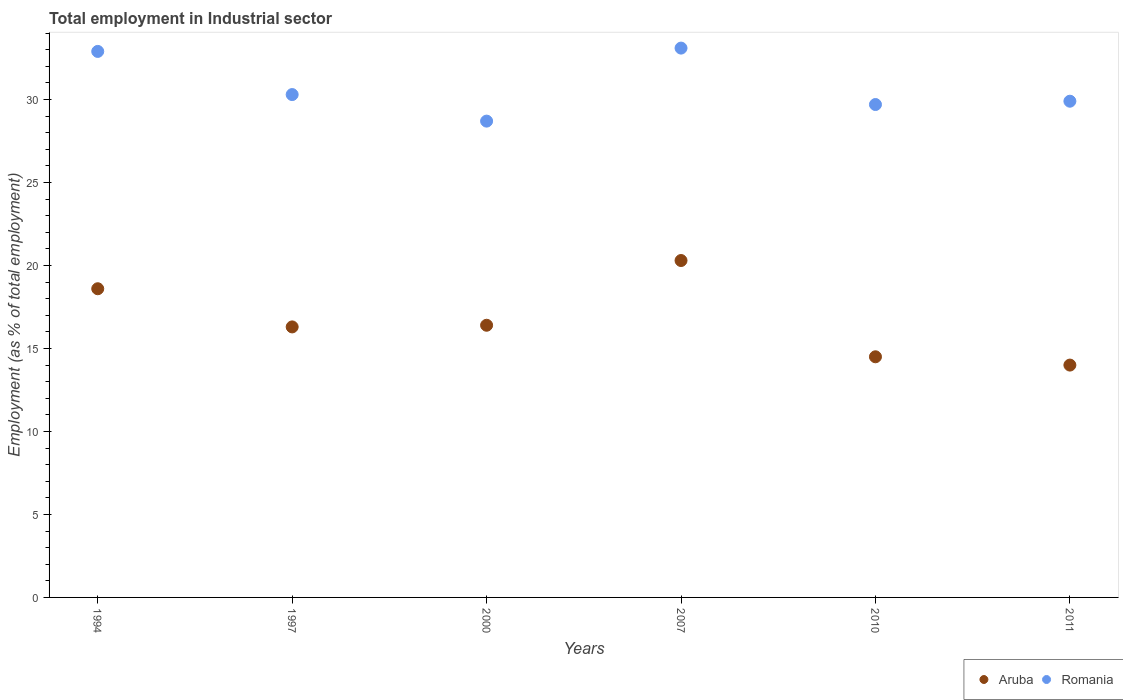How many different coloured dotlines are there?
Offer a terse response. 2. Is the number of dotlines equal to the number of legend labels?
Your answer should be compact. Yes. What is the employment in industrial sector in Romania in 2007?
Provide a short and direct response. 33.1. Across all years, what is the maximum employment in industrial sector in Aruba?
Make the answer very short. 20.3. Across all years, what is the minimum employment in industrial sector in Romania?
Give a very brief answer. 28.7. In which year was the employment in industrial sector in Romania maximum?
Provide a short and direct response. 2007. What is the total employment in industrial sector in Aruba in the graph?
Your answer should be very brief. 100.1. What is the difference between the employment in industrial sector in Romania in 1994 and that in 2011?
Your answer should be compact. 3. What is the difference between the employment in industrial sector in Romania in 1994 and the employment in industrial sector in Aruba in 1997?
Keep it short and to the point. 16.6. What is the average employment in industrial sector in Aruba per year?
Your response must be concise. 16.68. In the year 2007, what is the difference between the employment in industrial sector in Aruba and employment in industrial sector in Romania?
Offer a very short reply. -12.8. What is the ratio of the employment in industrial sector in Aruba in 1997 to that in 2011?
Your response must be concise. 1.16. Is the difference between the employment in industrial sector in Aruba in 1994 and 2000 greater than the difference between the employment in industrial sector in Romania in 1994 and 2000?
Offer a very short reply. No. What is the difference between the highest and the second highest employment in industrial sector in Aruba?
Provide a succinct answer. 1.7. What is the difference between the highest and the lowest employment in industrial sector in Romania?
Provide a succinct answer. 4.4. In how many years, is the employment in industrial sector in Romania greater than the average employment in industrial sector in Romania taken over all years?
Your response must be concise. 2. Is the sum of the employment in industrial sector in Aruba in 1994 and 1997 greater than the maximum employment in industrial sector in Romania across all years?
Provide a succinct answer. Yes. Does the employment in industrial sector in Aruba monotonically increase over the years?
Provide a short and direct response. No. Is the employment in industrial sector in Aruba strictly greater than the employment in industrial sector in Romania over the years?
Your answer should be very brief. No. Is the employment in industrial sector in Aruba strictly less than the employment in industrial sector in Romania over the years?
Make the answer very short. Yes. How many years are there in the graph?
Make the answer very short. 6. Does the graph contain grids?
Your answer should be compact. No. What is the title of the graph?
Ensure brevity in your answer.  Total employment in Industrial sector. Does "Puerto Rico" appear as one of the legend labels in the graph?
Give a very brief answer. No. What is the label or title of the Y-axis?
Offer a very short reply. Employment (as % of total employment). What is the Employment (as % of total employment) of Aruba in 1994?
Give a very brief answer. 18.6. What is the Employment (as % of total employment) of Romania in 1994?
Offer a terse response. 32.9. What is the Employment (as % of total employment) of Aruba in 1997?
Ensure brevity in your answer.  16.3. What is the Employment (as % of total employment) of Romania in 1997?
Give a very brief answer. 30.3. What is the Employment (as % of total employment) of Aruba in 2000?
Your answer should be very brief. 16.4. What is the Employment (as % of total employment) in Romania in 2000?
Give a very brief answer. 28.7. What is the Employment (as % of total employment) of Aruba in 2007?
Provide a succinct answer. 20.3. What is the Employment (as % of total employment) of Romania in 2007?
Give a very brief answer. 33.1. What is the Employment (as % of total employment) in Romania in 2010?
Your response must be concise. 29.7. What is the Employment (as % of total employment) of Romania in 2011?
Your response must be concise. 29.9. Across all years, what is the maximum Employment (as % of total employment) of Aruba?
Your response must be concise. 20.3. Across all years, what is the maximum Employment (as % of total employment) of Romania?
Give a very brief answer. 33.1. Across all years, what is the minimum Employment (as % of total employment) in Romania?
Provide a short and direct response. 28.7. What is the total Employment (as % of total employment) of Aruba in the graph?
Provide a short and direct response. 100.1. What is the total Employment (as % of total employment) of Romania in the graph?
Your answer should be very brief. 184.6. What is the difference between the Employment (as % of total employment) of Aruba in 1994 and that in 1997?
Your answer should be compact. 2.3. What is the difference between the Employment (as % of total employment) of Aruba in 1994 and that in 2000?
Your answer should be compact. 2.2. What is the difference between the Employment (as % of total employment) in Romania in 1994 and that in 2000?
Provide a succinct answer. 4.2. What is the difference between the Employment (as % of total employment) of Romania in 1994 and that in 2007?
Make the answer very short. -0.2. What is the difference between the Employment (as % of total employment) of Aruba in 1994 and that in 2010?
Provide a short and direct response. 4.1. What is the difference between the Employment (as % of total employment) of Romania in 1994 and that in 2010?
Offer a terse response. 3.2. What is the difference between the Employment (as % of total employment) in Aruba in 1994 and that in 2011?
Give a very brief answer. 4.6. What is the difference between the Employment (as % of total employment) of Romania in 1994 and that in 2011?
Offer a very short reply. 3. What is the difference between the Employment (as % of total employment) in Aruba in 1997 and that in 2000?
Provide a short and direct response. -0.1. What is the difference between the Employment (as % of total employment) in Romania in 1997 and that in 2000?
Your answer should be compact. 1.6. What is the difference between the Employment (as % of total employment) in Aruba in 1997 and that in 2010?
Give a very brief answer. 1.8. What is the difference between the Employment (as % of total employment) of Aruba in 1997 and that in 2011?
Your answer should be very brief. 2.3. What is the difference between the Employment (as % of total employment) of Romania in 1997 and that in 2011?
Your response must be concise. 0.4. What is the difference between the Employment (as % of total employment) of Romania in 2000 and that in 2007?
Offer a very short reply. -4.4. What is the difference between the Employment (as % of total employment) in Aruba in 2000 and that in 2010?
Offer a very short reply. 1.9. What is the difference between the Employment (as % of total employment) of Romania in 2000 and that in 2010?
Provide a short and direct response. -1. What is the difference between the Employment (as % of total employment) of Romania in 2000 and that in 2011?
Make the answer very short. -1.2. What is the difference between the Employment (as % of total employment) of Aruba in 2010 and that in 2011?
Provide a short and direct response. 0.5. What is the difference between the Employment (as % of total employment) of Aruba in 1994 and the Employment (as % of total employment) of Romania in 1997?
Your answer should be compact. -11.7. What is the difference between the Employment (as % of total employment) of Aruba in 1994 and the Employment (as % of total employment) of Romania in 2007?
Keep it short and to the point. -14.5. What is the difference between the Employment (as % of total employment) of Aruba in 1994 and the Employment (as % of total employment) of Romania in 2010?
Your answer should be very brief. -11.1. What is the difference between the Employment (as % of total employment) in Aruba in 1994 and the Employment (as % of total employment) in Romania in 2011?
Provide a succinct answer. -11.3. What is the difference between the Employment (as % of total employment) in Aruba in 1997 and the Employment (as % of total employment) in Romania in 2007?
Give a very brief answer. -16.8. What is the difference between the Employment (as % of total employment) of Aruba in 1997 and the Employment (as % of total employment) of Romania in 2010?
Ensure brevity in your answer.  -13.4. What is the difference between the Employment (as % of total employment) of Aruba in 2000 and the Employment (as % of total employment) of Romania in 2007?
Keep it short and to the point. -16.7. What is the difference between the Employment (as % of total employment) in Aruba in 2000 and the Employment (as % of total employment) in Romania in 2010?
Give a very brief answer. -13.3. What is the difference between the Employment (as % of total employment) in Aruba in 2000 and the Employment (as % of total employment) in Romania in 2011?
Provide a succinct answer. -13.5. What is the difference between the Employment (as % of total employment) of Aruba in 2007 and the Employment (as % of total employment) of Romania in 2010?
Offer a terse response. -9.4. What is the difference between the Employment (as % of total employment) in Aruba in 2007 and the Employment (as % of total employment) in Romania in 2011?
Your answer should be compact. -9.6. What is the difference between the Employment (as % of total employment) of Aruba in 2010 and the Employment (as % of total employment) of Romania in 2011?
Ensure brevity in your answer.  -15.4. What is the average Employment (as % of total employment) of Aruba per year?
Make the answer very short. 16.68. What is the average Employment (as % of total employment) of Romania per year?
Your answer should be very brief. 30.77. In the year 1994, what is the difference between the Employment (as % of total employment) in Aruba and Employment (as % of total employment) in Romania?
Ensure brevity in your answer.  -14.3. In the year 2000, what is the difference between the Employment (as % of total employment) of Aruba and Employment (as % of total employment) of Romania?
Offer a very short reply. -12.3. In the year 2007, what is the difference between the Employment (as % of total employment) in Aruba and Employment (as % of total employment) in Romania?
Offer a terse response. -12.8. In the year 2010, what is the difference between the Employment (as % of total employment) in Aruba and Employment (as % of total employment) in Romania?
Make the answer very short. -15.2. In the year 2011, what is the difference between the Employment (as % of total employment) in Aruba and Employment (as % of total employment) in Romania?
Offer a very short reply. -15.9. What is the ratio of the Employment (as % of total employment) of Aruba in 1994 to that in 1997?
Provide a succinct answer. 1.14. What is the ratio of the Employment (as % of total employment) in Romania in 1994 to that in 1997?
Provide a succinct answer. 1.09. What is the ratio of the Employment (as % of total employment) in Aruba in 1994 to that in 2000?
Keep it short and to the point. 1.13. What is the ratio of the Employment (as % of total employment) in Romania in 1994 to that in 2000?
Provide a succinct answer. 1.15. What is the ratio of the Employment (as % of total employment) in Aruba in 1994 to that in 2007?
Offer a very short reply. 0.92. What is the ratio of the Employment (as % of total employment) of Romania in 1994 to that in 2007?
Make the answer very short. 0.99. What is the ratio of the Employment (as % of total employment) in Aruba in 1994 to that in 2010?
Make the answer very short. 1.28. What is the ratio of the Employment (as % of total employment) in Romania in 1994 to that in 2010?
Make the answer very short. 1.11. What is the ratio of the Employment (as % of total employment) in Aruba in 1994 to that in 2011?
Provide a succinct answer. 1.33. What is the ratio of the Employment (as % of total employment) in Romania in 1994 to that in 2011?
Your answer should be very brief. 1.1. What is the ratio of the Employment (as % of total employment) in Romania in 1997 to that in 2000?
Your answer should be compact. 1.06. What is the ratio of the Employment (as % of total employment) in Aruba in 1997 to that in 2007?
Ensure brevity in your answer.  0.8. What is the ratio of the Employment (as % of total employment) of Romania in 1997 to that in 2007?
Your answer should be very brief. 0.92. What is the ratio of the Employment (as % of total employment) of Aruba in 1997 to that in 2010?
Keep it short and to the point. 1.12. What is the ratio of the Employment (as % of total employment) of Romania in 1997 to that in 2010?
Give a very brief answer. 1.02. What is the ratio of the Employment (as % of total employment) in Aruba in 1997 to that in 2011?
Your answer should be very brief. 1.16. What is the ratio of the Employment (as % of total employment) in Romania in 1997 to that in 2011?
Offer a very short reply. 1.01. What is the ratio of the Employment (as % of total employment) of Aruba in 2000 to that in 2007?
Your answer should be very brief. 0.81. What is the ratio of the Employment (as % of total employment) of Romania in 2000 to that in 2007?
Offer a terse response. 0.87. What is the ratio of the Employment (as % of total employment) in Aruba in 2000 to that in 2010?
Your answer should be compact. 1.13. What is the ratio of the Employment (as % of total employment) in Romania in 2000 to that in 2010?
Give a very brief answer. 0.97. What is the ratio of the Employment (as % of total employment) of Aruba in 2000 to that in 2011?
Provide a succinct answer. 1.17. What is the ratio of the Employment (as % of total employment) of Romania in 2000 to that in 2011?
Your answer should be very brief. 0.96. What is the ratio of the Employment (as % of total employment) in Romania in 2007 to that in 2010?
Ensure brevity in your answer.  1.11. What is the ratio of the Employment (as % of total employment) of Aruba in 2007 to that in 2011?
Make the answer very short. 1.45. What is the ratio of the Employment (as % of total employment) in Romania in 2007 to that in 2011?
Your response must be concise. 1.11. What is the ratio of the Employment (as % of total employment) of Aruba in 2010 to that in 2011?
Make the answer very short. 1.04. What is the ratio of the Employment (as % of total employment) of Romania in 2010 to that in 2011?
Your response must be concise. 0.99. What is the difference between the highest and the second highest Employment (as % of total employment) of Romania?
Provide a short and direct response. 0.2. What is the difference between the highest and the lowest Employment (as % of total employment) of Aruba?
Your response must be concise. 6.3. What is the difference between the highest and the lowest Employment (as % of total employment) in Romania?
Provide a short and direct response. 4.4. 